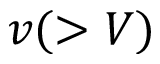<formula> <loc_0><loc_0><loc_500><loc_500>v ( > V )</formula> 